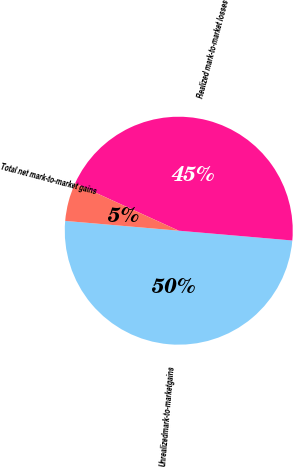Convert chart. <chart><loc_0><loc_0><loc_500><loc_500><pie_chart><fcel>Unrealizedmark-to-marketgains<fcel>Realized mark-to-market losses<fcel>Total net mark-to-market gains<nl><fcel>50.0%<fcel>44.55%<fcel>5.45%<nl></chart> 